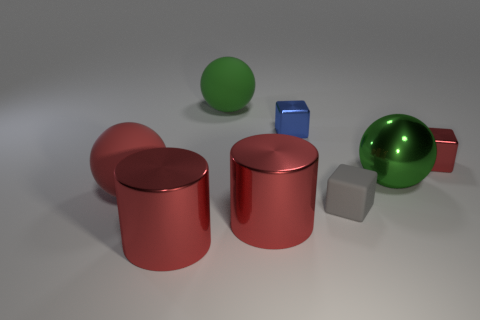Subtract all matte balls. How many balls are left? 1 Subtract all green balls. How many balls are left? 1 Add 2 green metal objects. How many objects exist? 10 Subtract 1 cylinders. How many cylinders are left? 1 Subtract all gray cylinders. How many green balls are left? 2 Add 5 large red cylinders. How many large red cylinders exist? 7 Subtract 0 purple cylinders. How many objects are left? 8 Subtract all cubes. How many objects are left? 5 Subtract all cyan balls. Subtract all gray blocks. How many balls are left? 3 Subtract all big green things. Subtract all tiny gray blocks. How many objects are left? 5 